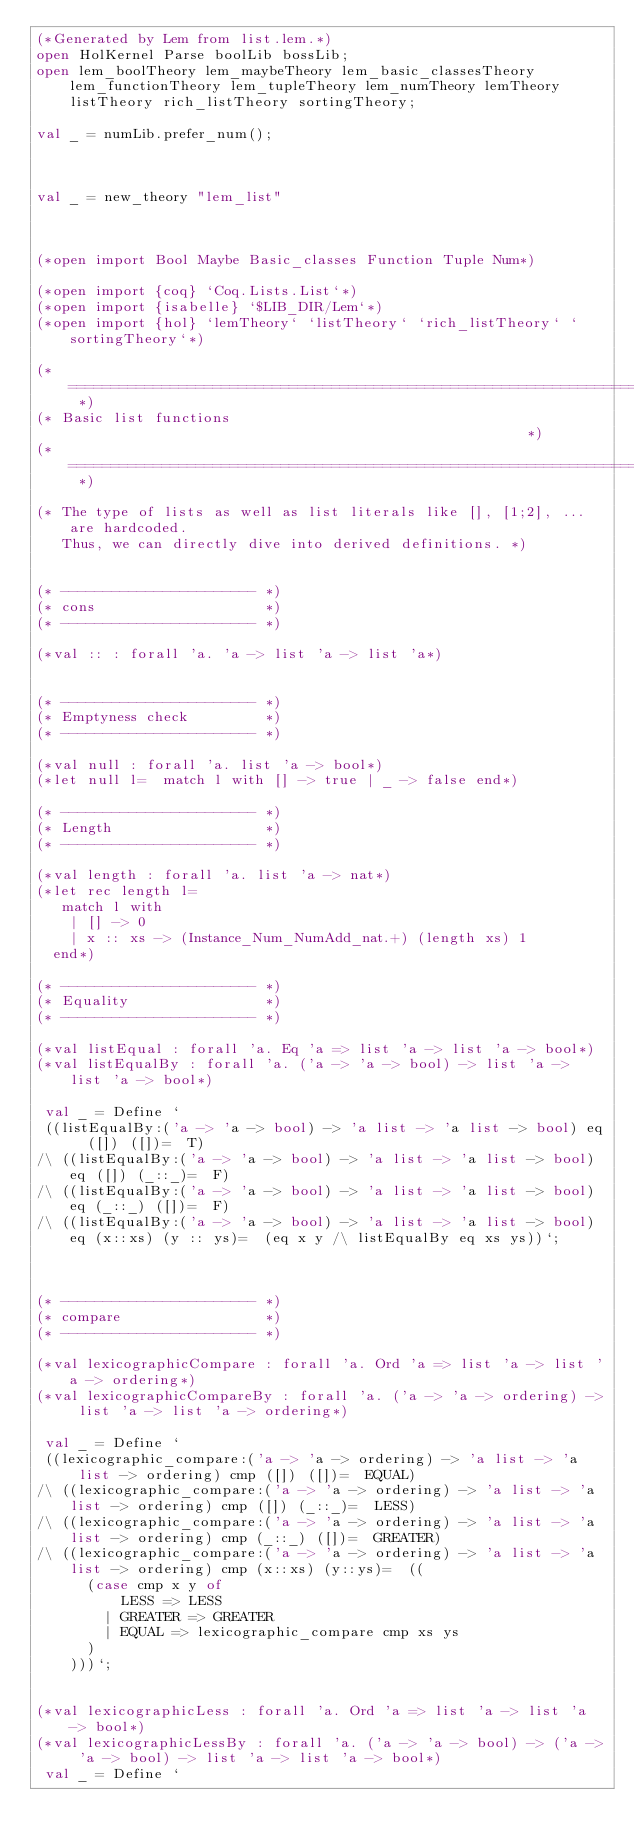Convert code to text. <code><loc_0><loc_0><loc_500><loc_500><_SML_>(*Generated by Lem from list.lem.*)
open HolKernel Parse boolLib bossLib;
open lem_boolTheory lem_maybeTheory lem_basic_classesTheory lem_functionTheory lem_tupleTheory lem_numTheory lemTheory listTheory rich_listTheory sortingTheory;

val _ = numLib.prefer_num();



val _ = new_theory "lem_list"

 

(*open import Bool Maybe Basic_classes Function Tuple Num*)

(*open import {coq} `Coq.Lists.List`*)
(*open import {isabelle} `$LIB_DIR/Lem`*)
(*open import {hol} `lemTheory` `listTheory` `rich_listTheory` `sortingTheory`*)

(* ========================================================================== *)
(* Basic list functions                                                       *)
(* ========================================================================== *)

(* The type of lists as well as list literals like [], [1;2], ... are hardcoded. 
   Thus, we can directly dive into derived definitions. *)


(* ----------------------- *)
(* cons                    *)
(* ----------------------- *)

(*val :: : forall 'a. 'a -> list 'a -> list 'a*)


(* ----------------------- *)
(* Emptyness check         *)
(* ----------------------- *)

(*val null : forall 'a. list 'a -> bool*)
(*let null l=  match l with [] -> true | _ -> false end*)

(* ----------------------- *)
(* Length                  *)
(* ----------------------- *)

(*val length : forall 'a. list 'a -> nat*)
(*let rec length l=
   match l with
    | [] -> 0
    | x :: xs -> (Instance_Num_NumAdd_nat.+) (length xs) 1
  end*)

(* ----------------------- *)
(* Equality                *)
(* ----------------------- *)

(*val listEqual : forall 'a. Eq 'a => list 'a -> list 'a -> bool*)
(*val listEqualBy : forall 'a. ('a -> 'a -> bool) -> list 'a -> list 'a -> bool*)

 val _ = Define `
 ((listEqualBy:('a -> 'a -> bool) -> 'a list -> 'a list -> bool) eq ([]) ([])=  T)
/\ ((listEqualBy:('a -> 'a -> bool) -> 'a list -> 'a list -> bool) eq ([]) (_::_)=  F)
/\ ((listEqualBy:('a -> 'a -> bool) -> 'a list -> 'a list -> bool) eq (_::_) ([])=  F)
/\ ((listEqualBy:('a -> 'a -> bool) -> 'a list -> 'a list -> bool) eq (x::xs) (y :: ys)=  (eq x y /\ listEqualBy eq xs ys))`;



(* ----------------------- *)
(* compare                 *)
(* ----------------------- *)

(*val lexicographicCompare : forall 'a. Ord 'a => list 'a -> list 'a -> ordering*)
(*val lexicographicCompareBy : forall 'a. ('a -> 'a -> ordering) -> list 'a -> list 'a -> ordering*)

 val _ = Define `
 ((lexicographic_compare:('a -> 'a -> ordering) -> 'a list -> 'a list -> ordering) cmp ([]) ([])=  EQUAL)
/\ ((lexicographic_compare:('a -> 'a -> ordering) -> 'a list -> 'a list -> ordering) cmp ([]) (_::_)=  LESS)
/\ ((lexicographic_compare:('a -> 'a -> ordering) -> 'a list -> 'a list -> ordering) cmp (_::_) ([])=  GREATER)
/\ ((lexicographic_compare:('a -> 'a -> ordering) -> 'a list -> 'a list -> ordering) cmp (x::xs) (y::ys)=  ((
      (case cmp x y of 
          LESS => LESS
        | GREATER => GREATER
        | EQUAL => lexicographic_compare cmp xs ys
      )
    )))`;


(*val lexicographicLess : forall 'a. Ord 'a => list 'a -> list 'a -> bool*)
(*val lexicographicLessBy : forall 'a. ('a -> 'a -> bool) -> ('a -> 'a -> bool) -> list 'a -> list 'a -> bool*)
 val _ = Define `</code> 